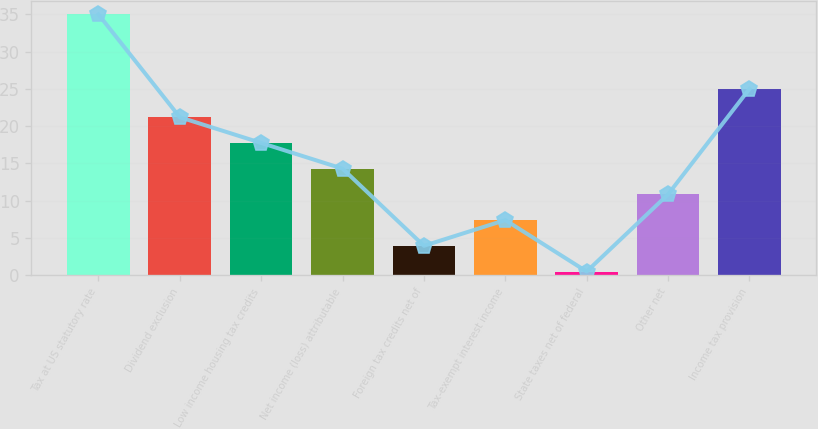<chart> <loc_0><loc_0><loc_500><loc_500><bar_chart><fcel>Tax at US statutory rate<fcel>Dividend exclusion<fcel>Low income housing tax credits<fcel>Net income (loss) attributable<fcel>Foreign tax credits net of<fcel>Tax-exempt interest income<fcel>State taxes net of federal<fcel>Other net<fcel>Income tax provision<nl><fcel>35<fcel>21.2<fcel>17.75<fcel>14.3<fcel>3.95<fcel>7.4<fcel>0.5<fcel>10.85<fcel>25<nl></chart> 